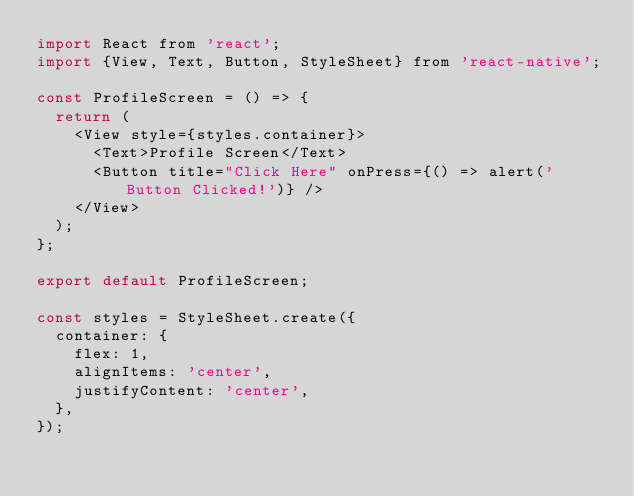<code> <loc_0><loc_0><loc_500><loc_500><_JavaScript_>import React from 'react';
import {View, Text, Button, StyleSheet} from 'react-native';

const ProfileScreen = () => {
  return (
    <View style={styles.container}>
      <Text>Profile Screen</Text>
      <Button title="Click Here" onPress={() => alert('Button Clicked!')} />
    </View>
  );
};

export default ProfileScreen;

const styles = StyleSheet.create({
  container: {
    flex: 1,
    alignItems: 'center',
    justifyContent: 'center',
  },
});
</code> 